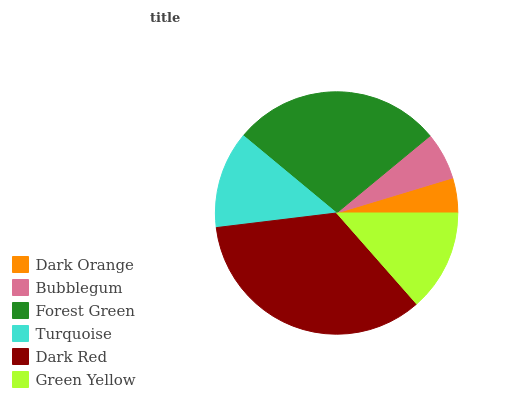Is Dark Orange the minimum?
Answer yes or no. Yes. Is Dark Red the maximum?
Answer yes or no. Yes. Is Bubblegum the minimum?
Answer yes or no. No. Is Bubblegum the maximum?
Answer yes or no. No. Is Bubblegum greater than Dark Orange?
Answer yes or no. Yes. Is Dark Orange less than Bubblegum?
Answer yes or no. Yes. Is Dark Orange greater than Bubblegum?
Answer yes or no. No. Is Bubblegum less than Dark Orange?
Answer yes or no. No. Is Green Yellow the high median?
Answer yes or no. Yes. Is Turquoise the low median?
Answer yes or no. Yes. Is Bubblegum the high median?
Answer yes or no. No. Is Bubblegum the low median?
Answer yes or no. No. 